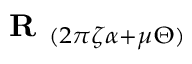Convert formula to latex. <formula><loc_0><loc_0><loc_500><loc_500>{ R } _ { ( 2 \pi \zeta \alpha + \mu \Theta ) }</formula> 